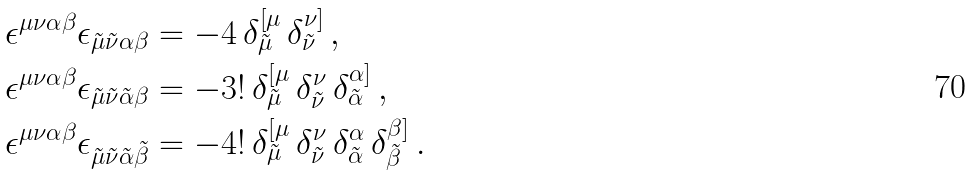Convert formula to latex. <formula><loc_0><loc_0><loc_500><loc_500>\epsilon ^ { \mu \nu \alpha \beta } \epsilon _ { \tilde { \mu } \tilde { \nu } \alpha \beta } & = - 4 \, \delta ^ { [ \mu } _ { \tilde { \mu } } \, \delta ^ { \nu ] } _ { \tilde { \nu } } \, , \\ \epsilon ^ { \mu \nu \alpha \beta } \epsilon _ { \tilde { \mu } \tilde { \nu } \tilde { \alpha } \beta } & = - 3 \mathcal { ! } \, \delta ^ { [ \mu } _ { \tilde { \mu } } \, \delta ^ { \nu } _ { \tilde { \nu } } \, \delta ^ { \alpha ] } _ { \tilde { \alpha } } \, , \\ \epsilon ^ { \mu \nu \alpha \beta } \epsilon _ { \tilde { \mu } \tilde { \nu } \tilde { \alpha } \tilde { \beta } } & = - 4 \mathcal { ! } \, \delta ^ { [ \mu } _ { \tilde { \mu } } \, \delta ^ { \nu } _ { \tilde { \nu } } \, \delta ^ { \alpha } _ { \tilde { \alpha } } \, \delta ^ { \beta ] } _ { \tilde { \beta } } \, .</formula> 